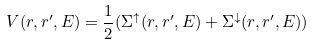Convert formula to latex. <formula><loc_0><loc_0><loc_500><loc_500>V ( { r } , { r } ^ { \prime } , E ) = \frac { 1 } { 2 } ( { \Sigma } ^ { \uparrow } ( { r } , { r } ^ { \prime } , E ) + { \Sigma } ^ { \downarrow } ( { r } , { r } ^ { \prime } , E ) )</formula> 